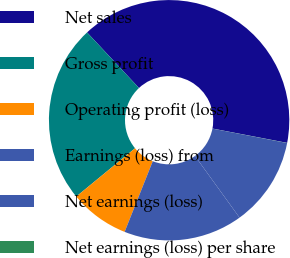Convert chart to OTSL. <chart><loc_0><loc_0><loc_500><loc_500><pie_chart><fcel>Net sales<fcel>Gross profit<fcel>Operating profit (loss)<fcel>Earnings (loss) from<fcel>Net earnings (loss)<fcel>Net earnings (loss) per share<nl><fcel>39.98%<fcel>23.99%<fcel>8.01%<fcel>16.0%<fcel>12.0%<fcel>0.02%<nl></chart> 